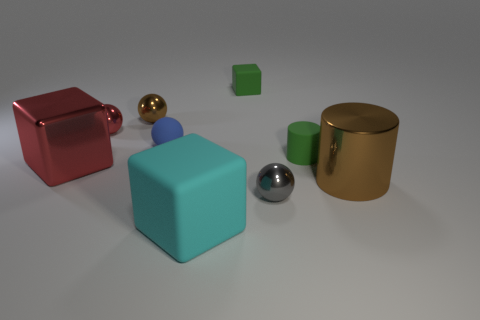The brown metallic object on the left side of the brown object that is to the right of the cylinder that is on the left side of the brown cylinder is what shape? The small brown metallic sphere positioned to the left of a dark brown cube, itself located to the right of a light blue cylinder, is indeed a sphere. The sphere's polished surface reflects the light elegantly, distinguishing it from other shapes. 